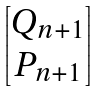Convert formula to latex. <formula><loc_0><loc_0><loc_500><loc_500>\begin{bmatrix} Q _ { n + 1 } \\ P _ { n + 1 } \end{bmatrix}</formula> 